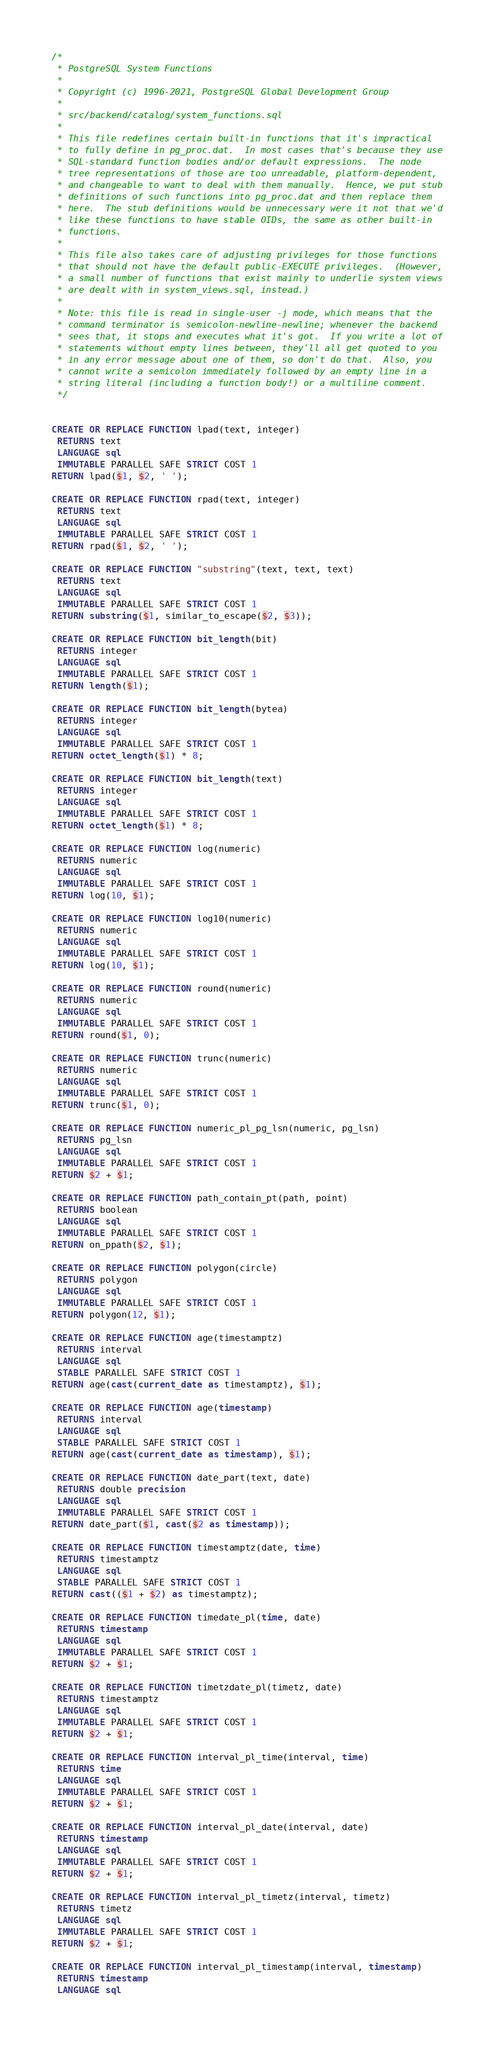<code> <loc_0><loc_0><loc_500><loc_500><_SQL_>/*
 * PostgreSQL System Functions
 *
 * Copyright (c) 1996-2021, PostgreSQL Global Development Group
 *
 * src/backend/catalog/system_functions.sql
 *
 * This file redefines certain built-in functions that it's impractical
 * to fully define in pg_proc.dat.  In most cases that's because they use
 * SQL-standard function bodies and/or default expressions.  The node
 * tree representations of those are too unreadable, platform-dependent,
 * and changeable to want to deal with them manually.  Hence, we put stub
 * definitions of such functions into pg_proc.dat and then replace them
 * here.  The stub definitions would be unnecessary were it not that we'd
 * like these functions to have stable OIDs, the same as other built-in
 * functions.
 *
 * This file also takes care of adjusting privileges for those functions
 * that should not have the default public-EXECUTE privileges.  (However,
 * a small number of functions that exist mainly to underlie system views
 * are dealt with in system_views.sql, instead.)
 *
 * Note: this file is read in single-user -j mode, which means that the
 * command terminator is semicolon-newline-newline; whenever the backend
 * sees that, it stops and executes what it's got.  If you write a lot of
 * statements without empty lines between, they'll all get quoted to you
 * in any error message about one of them, so don't do that.  Also, you
 * cannot write a semicolon immediately followed by an empty line in a
 * string literal (including a function body!) or a multiline comment.
 */


CREATE OR REPLACE FUNCTION lpad(text, integer)
 RETURNS text
 LANGUAGE sql
 IMMUTABLE PARALLEL SAFE STRICT COST 1
RETURN lpad($1, $2, ' ');

CREATE OR REPLACE FUNCTION rpad(text, integer)
 RETURNS text
 LANGUAGE sql
 IMMUTABLE PARALLEL SAFE STRICT COST 1
RETURN rpad($1, $2, ' ');

CREATE OR REPLACE FUNCTION "substring"(text, text, text)
 RETURNS text
 LANGUAGE sql
 IMMUTABLE PARALLEL SAFE STRICT COST 1
RETURN substring($1, similar_to_escape($2, $3));

CREATE OR REPLACE FUNCTION bit_length(bit)
 RETURNS integer
 LANGUAGE sql
 IMMUTABLE PARALLEL SAFE STRICT COST 1
RETURN length($1);

CREATE OR REPLACE FUNCTION bit_length(bytea)
 RETURNS integer
 LANGUAGE sql
 IMMUTABLE PARALLEL SAFE STRICT COST 1
RETURN octet_length($1) * 8;

CREATE OR REPLACE FUNCTION bit_length(text)
 RETURNS integer
 LANGUAGE sql
 IMMUTABLE PARALLEL SAFE STRICT COST 1
RETURN octet_length($1) * 8;

CREATE OR REPLACE FUNCTION log(numeric)
 RETURNS numeric
 LANGUAGE sql
 IMMUTABLE PARALLEL SAFE STRICT COST 1
RETURN log(10, $1);

CREATE OR REPLACE FUNCTION log10(numeric)
 RETURNS numeric
 LANGUAGE sql
 IMMUTABLE PARALLEL SAFE STRICT COST 1
RETURN log(10, $1);

CREATE OR REPLACE FUNCTION round(numeric)
 RETURNS numeric
 LANGUAGE sql
 IMMUTABLE PARALLEL SAFE STRICT COST 1
RETURN round($1, 0);

CREATE OR REPLACE FUNCTION trunc(numeric)
 RETURNS numeric
 LANGUAGE sql
 IMMUTABLE PARALLEL SAFE STRICT COST 1
RETURN trunc($1, 0);

CREATE OR REPLACE FUNCTION numeric_pl_pg_lsn(numeric, pg_lsn)
 RETURNS pg_lsn
 LANGUAGE sql
 IMMUTABLE PARALLEL SAFE STRICT COST 1
RETURN $2 + $1;

CREATE OR REPLACE FUNCTION path_contain_pt(path, point)
 RETURNS boolean
 LANGUAGE sql
 IMMUTABLE PARALLEL SAFE STRICT COST 1
RETURN on_ppath($2, $1);

CREATE OR REPLACE FUNCTION polygon(circle)
 RETURNS polygon
 LANGUAGE sql
 IMMUTABLE PARALLEL SAFE STRICT COST 1
RETURN polygon(12, $1);

CREATE OR REPLACE FUNCTION age(timestamptz)
 RETURNS interval
 LANGUAGE sql
 STABLE PARALLEL SAFE STRICT COST 1
RETURN age(cast(current_date as timestamptz), $1);

CREATE OR REPLACE FUNCTION age(timestamp)
 RETURNS interval
 LANGUAGE sql
 STABLE PARALLEL SAFE STRICT COST 1
RETURN age(cast(current_date as timestamp), $1);

CREATE OR REPLACE FUNCTION date_part(text, date)
 RETURNS double precision
 LANGUAGE sql
 IMMUTABLE PARALLEL SAFE STRICT COST 1
RETURN date_part($1, cast($2 as timestamp));

CREATE OR REPLACE FUNCTION timestamptz(date, time)
 RETURNS timestamptz
 LANGUAGE sql
 STABLE PARALLEL SAFE STRICT COST 1
RETURN cast(($1 + $2) as timestamptz);

CREATE OR REPLACE FUNCTION timedate_pl(time, date)
 RETURNS timestamp
 LANGUAGE sql
 IMMUTABLE PARALLEL SAFE STRICT COST 1
RETURN $2 + $1;

CREATE OR REPLACE FUNCTION timetzdate_pl(timetz, date)
 RETURNS timestamptz
 LANGUAGE sql
 IMMUTABLE PARALLEL SAFE STRICT COST 1
RETURN $2 + $1;

CREATE OR REPLACE FUNCTION interval_pl_time(interval, time)
 RETURNS time
 LANGUAGE sql
 IMMUTABLE PARALLEL SAFE STRICT COST 1
RETURN $2 + $1;

CREATE OR REPLACE FUNCTION interval_pl_date(interval, date)
 RETURNS timestamp
 LANGUAGE sql
 IMMUTABLE PARALLEL SAFE STRICT COST 1
RETURN $2 + $1;

CREATE OR REPLACE FUNCTION interval_pl_timetz(interval, timetz)
 RETURNS timetz
 LANGUAGE sql
 IMMUTABLE PARALLEL SAFE STRICT COST 1
RETURN $2 + $1;

CREATE OR REPLACE FUNCTION interval_pl_timestamp(interval, timestamp)
 RETURNS timestamp
 LANGUAGE sql</code> 